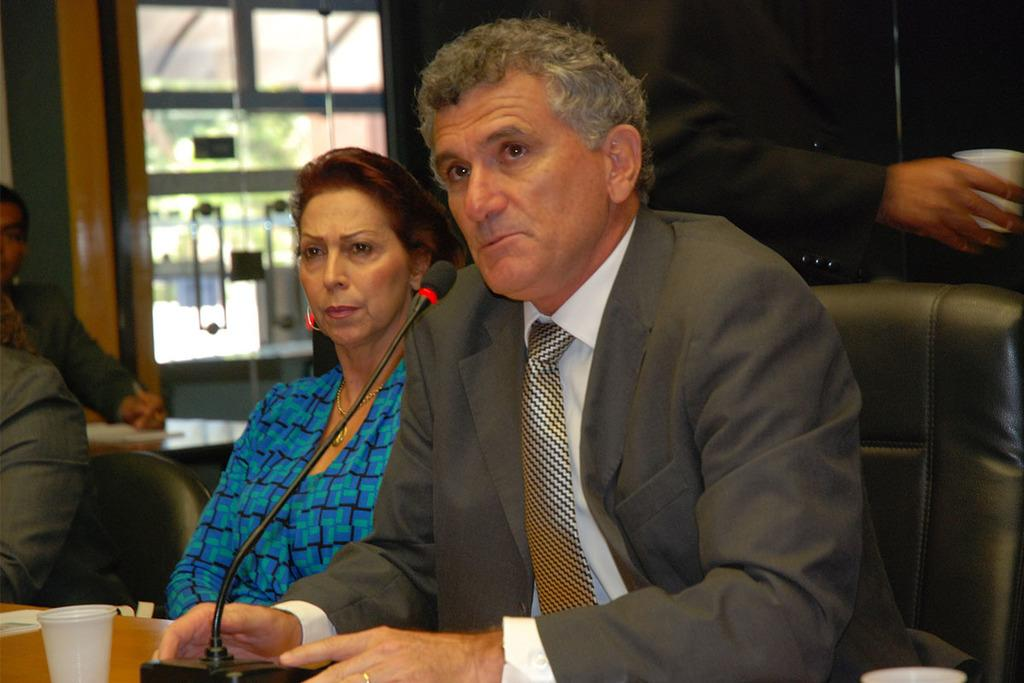What are the people in the image doing? The people in the image are sitting on chairs. What is the person holding in the image? The person is holding a glass in the image. What is present on the table in the image? There is a table in the image, and on it, there is a glass and a microphone. What can be seen in the background of the image? There is a glass door in the background of the image. What type of shoes can be seen on the person holding the glass in the image? There is no mention of shoes in the image, so it cannot be determined what type of shoes the person is wearing. 